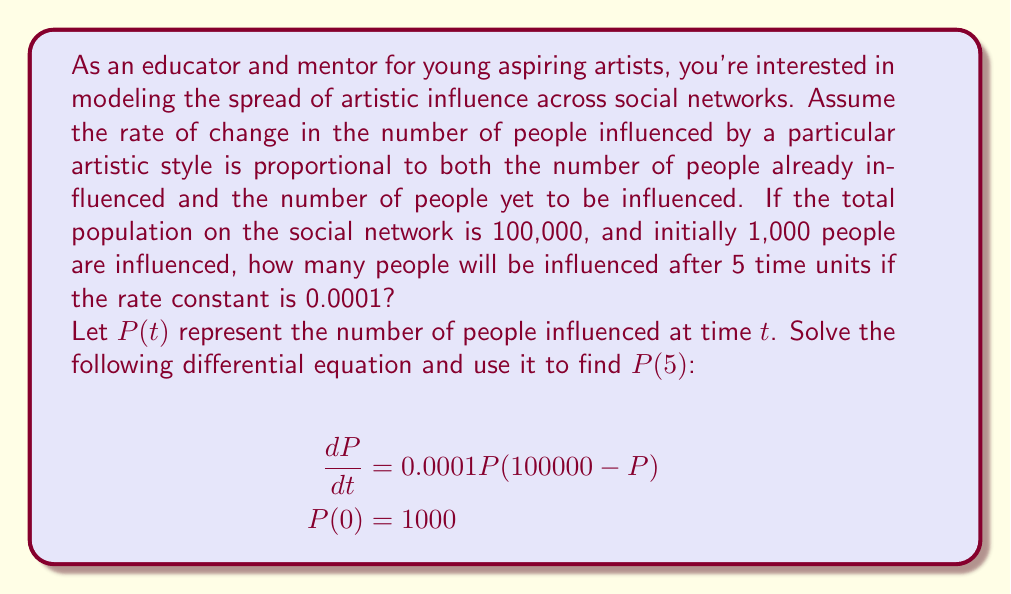Help me with this question. To solve this problem, we need to follow these steps:

1) Recognize that this is a logistic growth equation in the form:

   $$\frac{dP}{dt} = kP(M - P)$$

   where $k = 0.0001$ and $M = 100000$.

2) The solution to the logistic equation is:

   $$P(t) = \frac{M}{1 + Ce^{-kMt}}$$

   where $C$ is a constant we need to determine from the initial condition.

3) Using the initial condition $P(0) = 1000$, we can find $C$:

   $$1000 = \frac{100000}{1 + C}$$
   $$C = \frac{100000}{1000} - 1 = 99$$

4) Now our solution is:

   $$P(t) = \frac{100000}{1 + 99e^{-10t}}$$

5) To find $P(5)$, we simply substitute $t = 5$:

   $$P(5) = \frac{100000}{1 + 99e^{-50}}$$

6) Using a calculator to evaluate this expression:

   $$P(5) \approx 7432.45$$

Therefore, after 5 time units, approximately 7,432 people will be influenced by the artistic style.
Answer: $P(5) \approx 7432$ people 